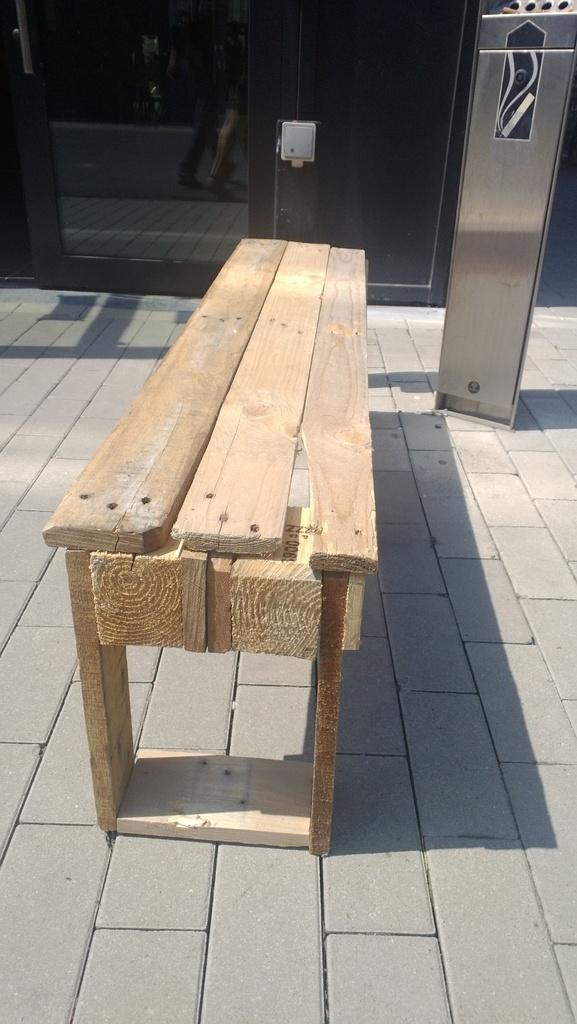What type of seating is visible in the image? There is a wooden bench in the image. Where is the bench located? The bench is on a path. What can be seen in the background of the image? There are people walking in the background of the image. On what surface are the people walking? The people are on a road. What type of grass is growing on the shoes of the people walking in the image? There is no grass growing on the shoes of the people walking in the image. How many cars can be seen parked near the wooden bench in the image? There are no cars visible in the image; it only features a wooden bench, a path, and people walking in the background. 